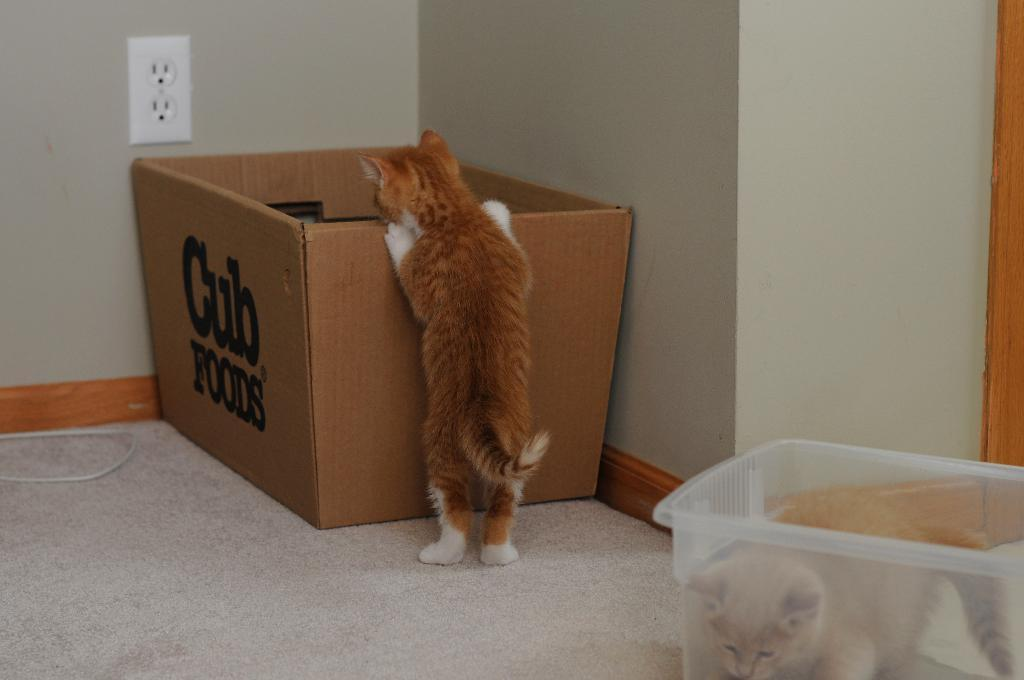Provide a one-sentence caption for the provided image. Brown cat standing on a cub food box. 